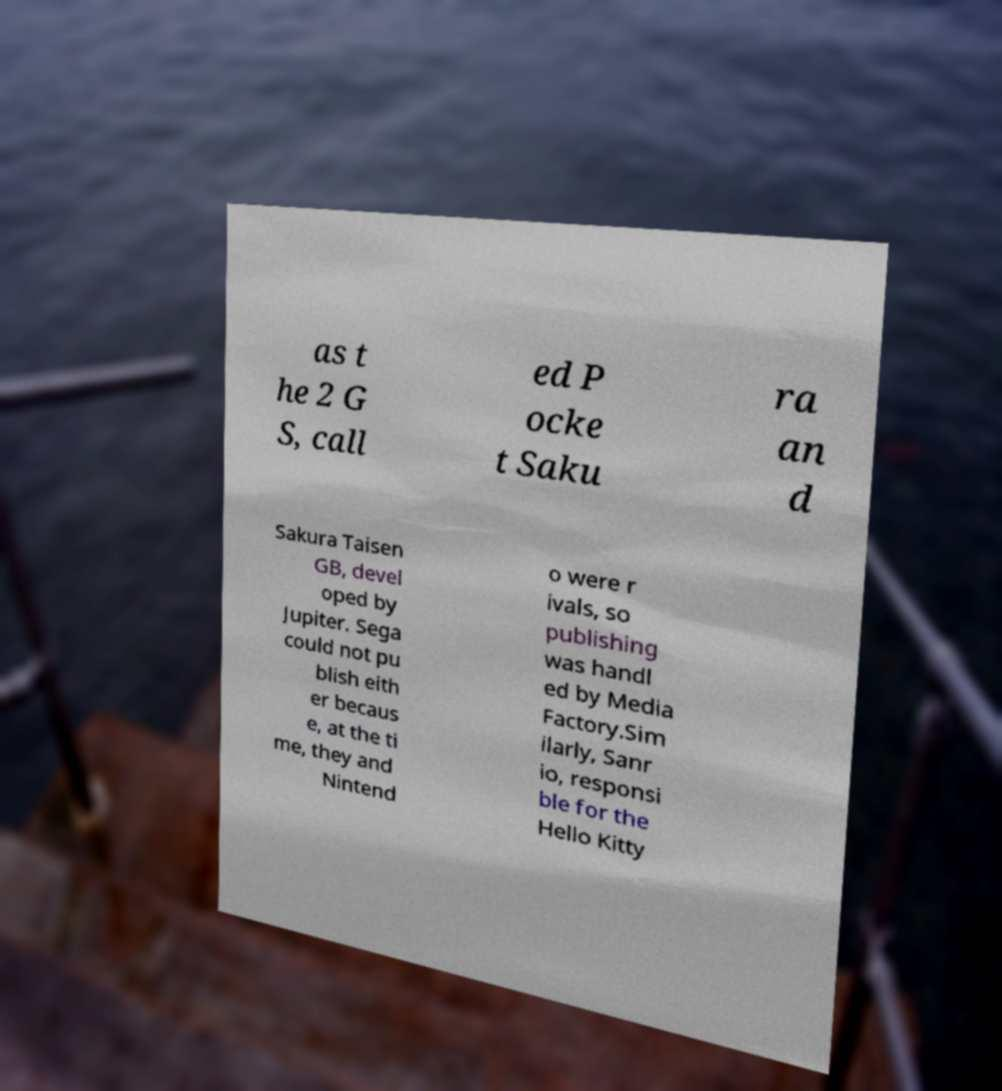For documentation purposes, I need the text within this image transcribed. Could you provide that? as t he 2 G S, call ed P ocke t Saku ra an d Sakura Taisen GB, devel oped by Jupiter. Sega could not pu blish eith er becaus e, at the ti me, they and Nintend o were r ivals, so publishing was handl ed by Media Factory.Sim ilarly, Sanr io, responsi ble for the Hello Kitty 